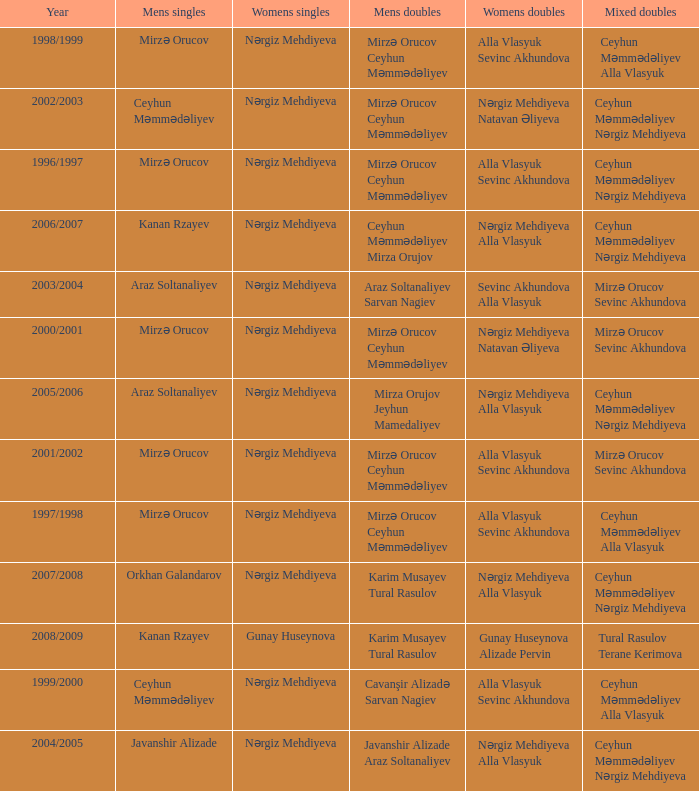Who were all womens doubles for the year 2000/2001? Nərgiz Mehdiyeva Natavan Əliyeva. 